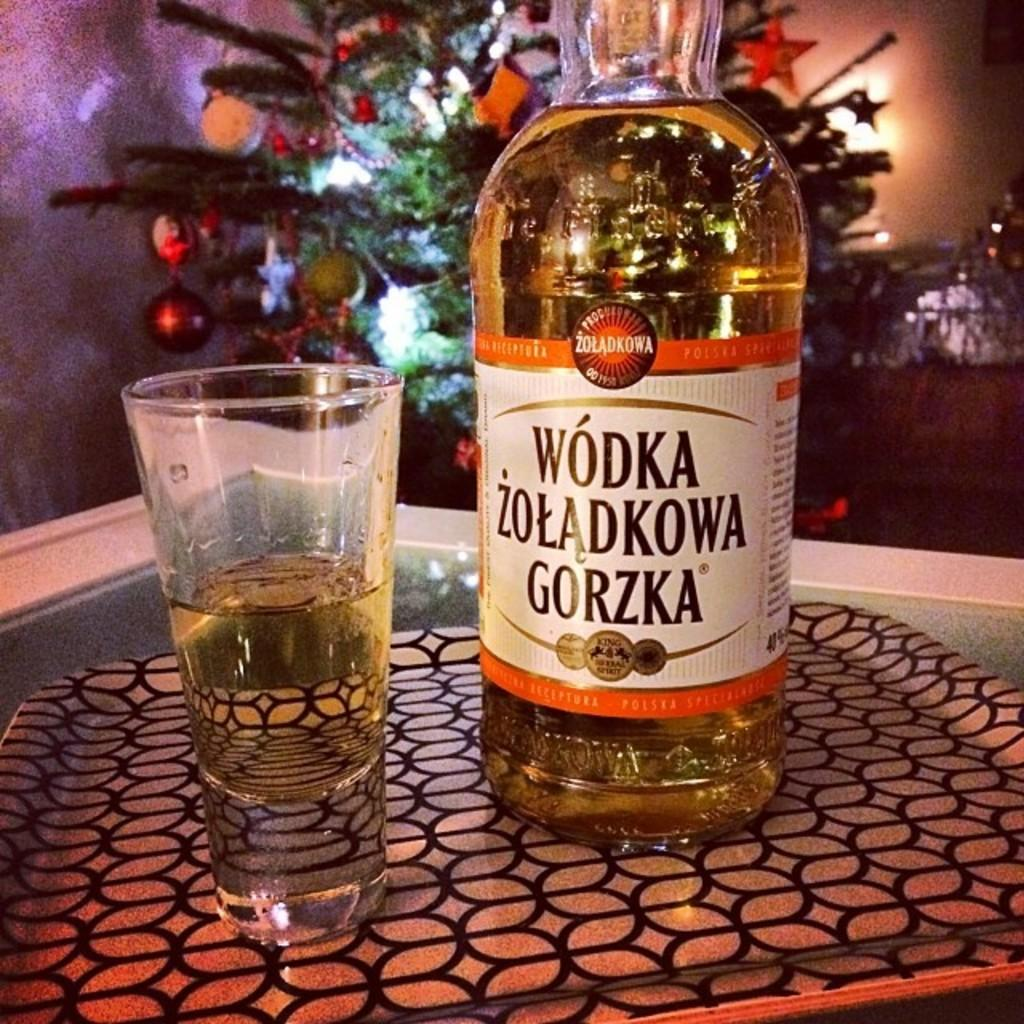<image>
Write a terse but informative summary of the picture. A bottle of Wodka Zoladkowa Gorzka next to a shot glass. 